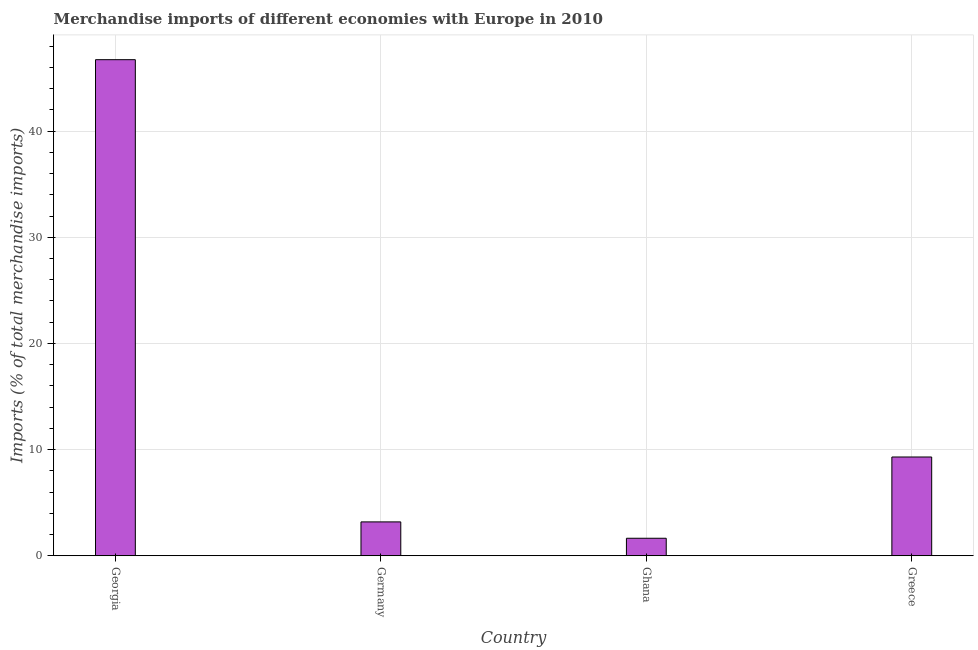What is the title of the graph?
Give a very brief answer. Merchandise imports of different economies with Europe in 2010. What is the label or title of the X-axis?
Your response must be concise. Country. What is the label or title of the Y-axis?
Make the answer very short. Imports (% of total merchandise imports). What is the merchandise imports in Greece?
Make the answer very short. 9.31. Across all countries, what is the maximum merchandise imports?
Provide a short and direct response. 46.73. Across all countries, what is the minimum merchandise imports?
Your answer should be very brief. 1.65. In which country was the merchandise imports maximum?
Your answer should be compact. Georgia. In which country was the merchandise imports minimum?
Your answer should be compact. Ghana. What is the sum of the merchandise imports?
Your answer should be very brief. 60.88. What is the difference between the merchandise imports in Germany and Greece?
Your response must be concise. -6.11. What is the average merchandise imports per country?
Your answer should be compact. 15.22. What is the median merchandise imports?
Give a very brief answer. 6.25. What is the ratio of the merchandise imports in Georgia to that in Greece?
Make the answer very short. 5.02. Is the merchandise imports in Georgia less than that in Ghana?
Your answer should be compact. No. Is the difference between the merchandise imports in Germany and Ghana greater than the difference between any two countries?
Offer a very short reply. No. What is the difference between the highest and the second highest merchandise imports?
Provide a succinct answer. 37.42. What is the difference between the highest and the lowest merchandise imports?
Offer a very short reply. 45.08. How many bars are there?
Your answer should be very brief. 4. Are all the bars in the graph horizontal?
Ensure brevity in your answer.  No. What is the difference between two consecutive major ticks on the Y-axis?
Your answer should be very brief. 10. What is the Imports (% of total merchandise imports) of Georgia?
Give a very brief answer. 46.73. What is the Imports (% of total merchandise imports) in Germany?
Your answer should be very brief. 3.19. What is the Imports (% of total merchandise imports) in Ghana?
Your answer should be very brief. 1.65. What is the Imports (% of total merchandise imports) of Greece?
Offer a very short reply. 9.31. What is the difference between the Imports (% of total merchandise imports) in Georgia and Germany?
Your answer should be very brief. 43.53. What is the difference between the Imports (% of total merchandise imports) in Georgia and Ghana?
Provide a short and direct response. 45.08. What is the difference between the Imports (% of total merchandise imports) in Georgia and Greece?
Your response must be concise. 37.42. What is the difference between the Imports (% of total merchandise imports) in Germany and Ghana?
Provide a succinct answer. 1.54. What is the difference between the Imports (% of total merchandise imports) in Germany and Greece?
Your answer should be very brief. -6.11. What is the difference between the Imports (% of total merchandise imports) in Ghana and Greece?
Your answer should be compact. -7.65. What is the ratio of the Imports (% of total merchandise imports) in Georgia to that in Germany?
Provide a short and direct response. 14.64. What is the ratio of the Imports (% of total merchandise imports) in Georgia to that in Ghana?
Your response must be concise. 28.3. What is the ratio of the Imports (% of total merchandise imports) in Georgia to that in Greece?
Offer a terse response. 5.02. What is the ratio of the Imports (% of total merchandise imports) in Germany to that in Ghana?
Your answer should be compact. 1.93. What is the ratio of the Imports (% of total merchandise imports) in Germany to that in Greece?
Offer a very short reply. 0.34. What is the ratio of the Imports (% of total merchandise imports) in Ghana to that in Greece?
Provide a succinct answer. 0.18. 